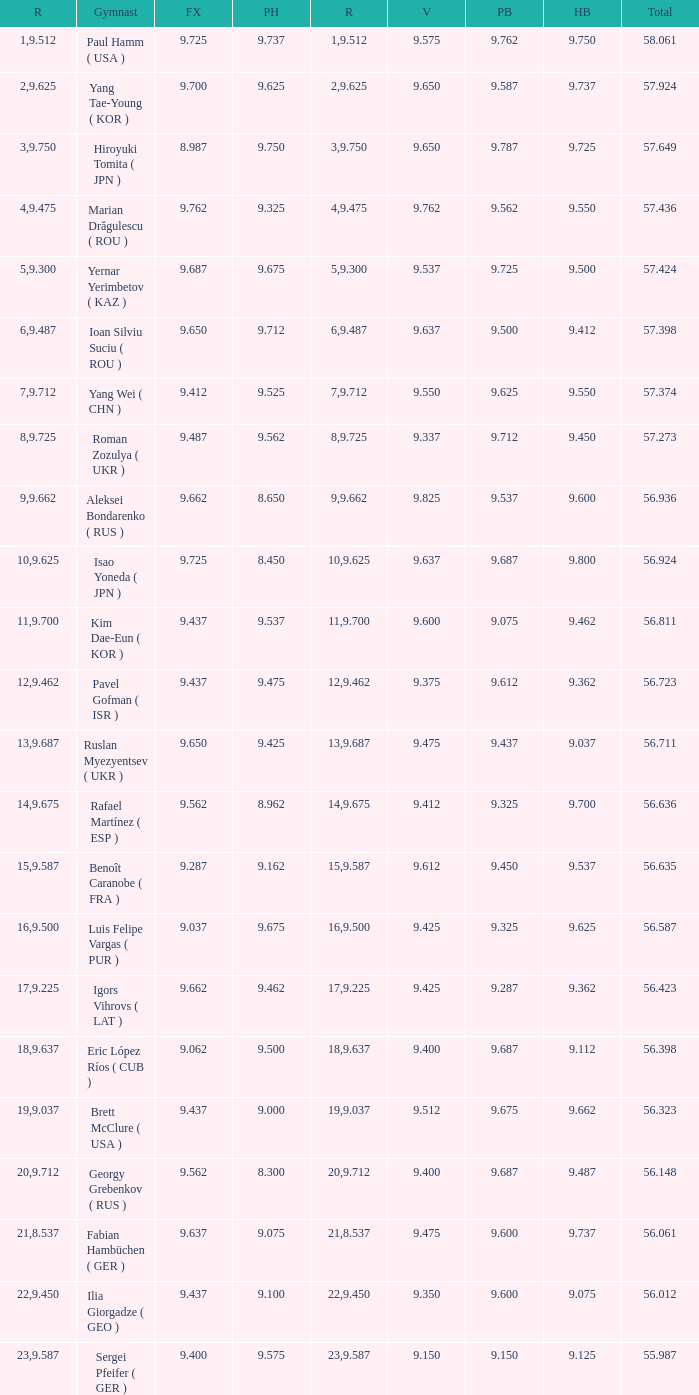What is the vault score for the total of 56.635? 9.612. 